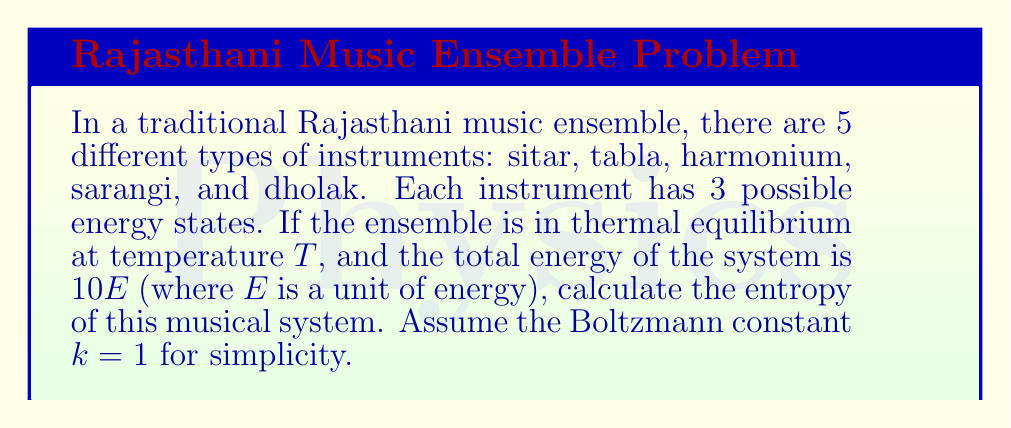Give your solution to this math problem. Let's approach this step-by-step:

1) First, we need to calculate the number of microstates (W) for this system. With 5 instruments, each having 3 possible energy states, the total number of microstates is:

   $$W = 3^5 = 243$$

2) Now, we need to use the Boltzmann entropy formula:

   $$S = k \ln W$$

   Where S is entropy, k is the Boltzmann constant (given as 1 for simplicity), and W is the number of microstates.

3) Substituting our values:

   $$S = 1 \cdot \ln 243$$

4) Calculate:

   $$S = \ln 243 \approx 5.493$$

5) The units of entropy in this case would be the same as the Boltzmann constant, which is typically J/K (Joules per Kelvin). However, since we're using k = 1 and not specifying units, we can leave the result as a dimensionless quantity.

Note: The total energy of the system (10E) doesn't directly factor into this calculation of entropy, as we're assuming a uniform distribution among the available microstates in thermal equilibrium. If we had information about the energy distribution among the states, we would need to use a more complex formula involving the partition function.
Answer: $$5.493$$ 